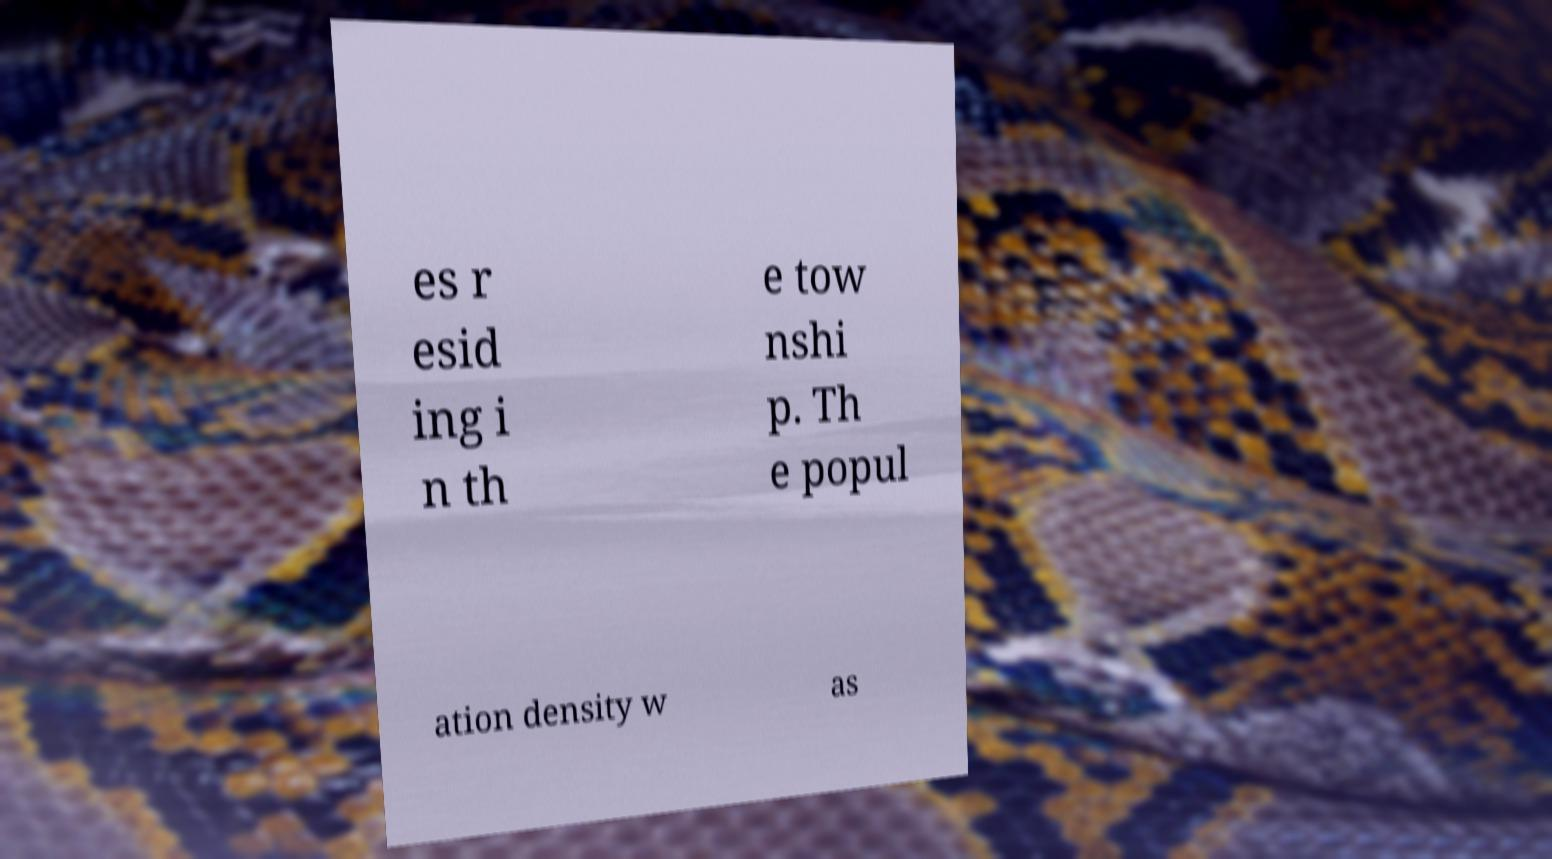Could you assist in decoding the text presented in this image and type it out clearly? es r esid ing i n th e tow nshi p. Th e popul ation density w as 